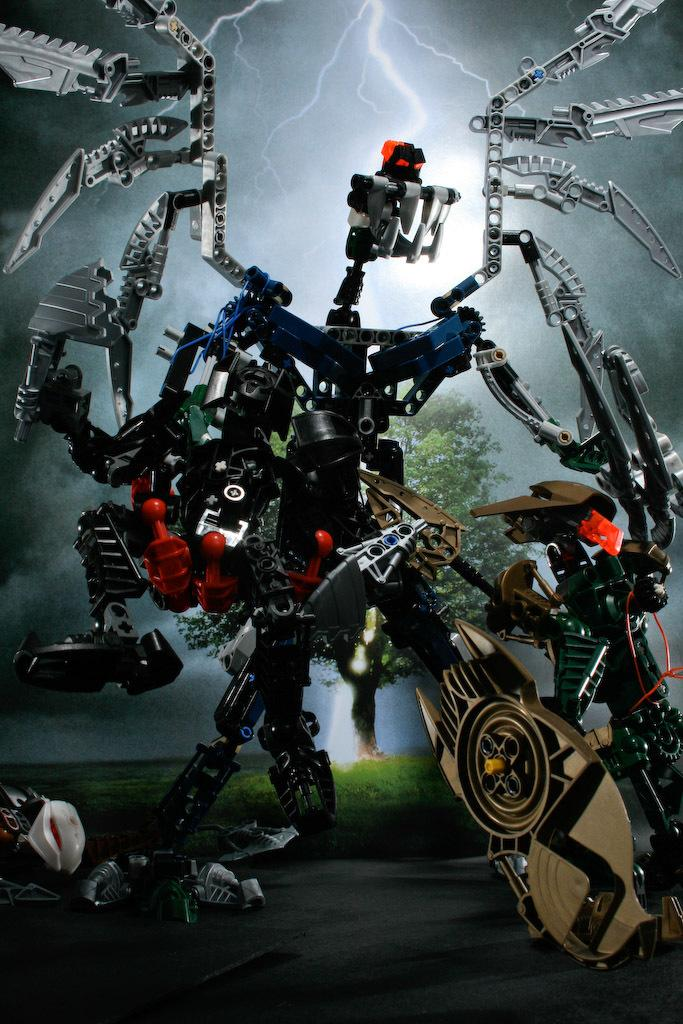What is the main subject in the middle of the image? There is a robot in the middle of the image. Where is the robot located? The robot is on the road. What can be seen in the background of the image? There is grass, a tree, clouds, and the moon visible in the background. What is the weather like in the image? The presence of clouds and the moon suggests it is nighttime, and the thunder indicates a stormy atmosphere. What type of hot experience can be felt by the robot in the image? There is no indication in the image that the robot is experiencing any heat or temperature-related sensations. 